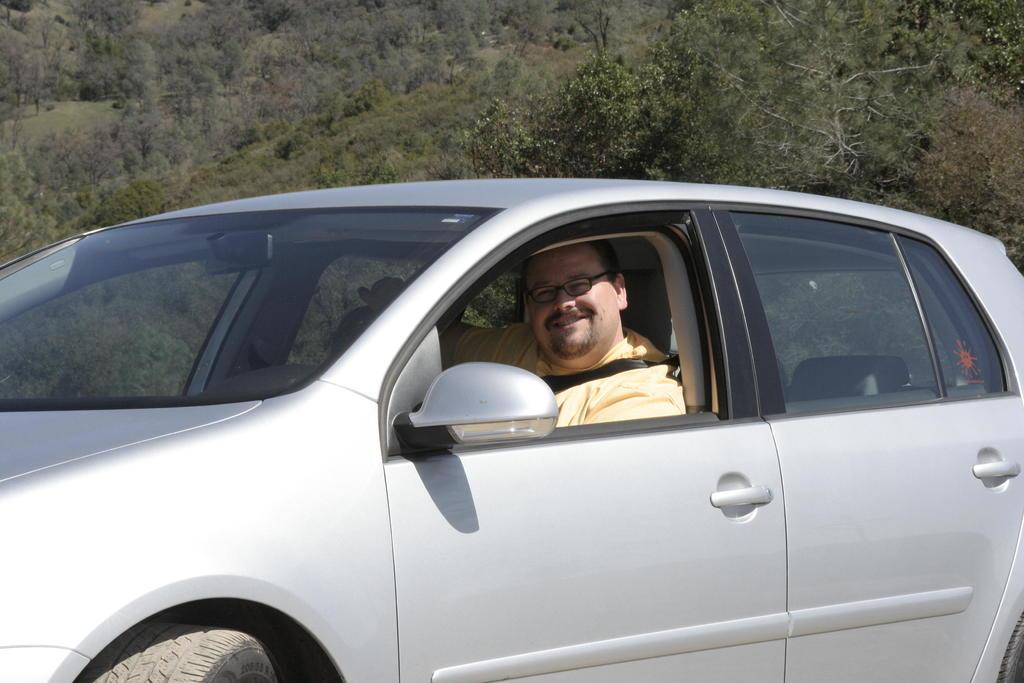What is the person in the image doing? There is a person riding a car in the image. What can be seen in the distance behind the car? There is a mountain visible in the background of the image. What type of vegetation is present in the background of the image? There are trees present in the background of the image. What type of tent can be seen in the image? There is no tent present in the image. What color is the person's shirt in the image? The provided facts do not mention the color of the person's shirt, so we cannot answer that question. 